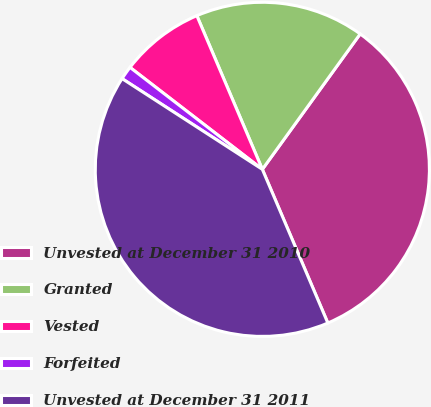<chart> <loc_0><loc_0><loc_500><loc_500><pie_chart><fcel>Unvested at December 31 2010<fcel>Granted<fcel>Vested<fcel>Forfeited<fcel>Unvested at December 31 2011<nl><fcel>33.63%<fcel>16.37%<fcel>8.14%<fcel>1.31%<fcel>40.55%<nl></chart> 